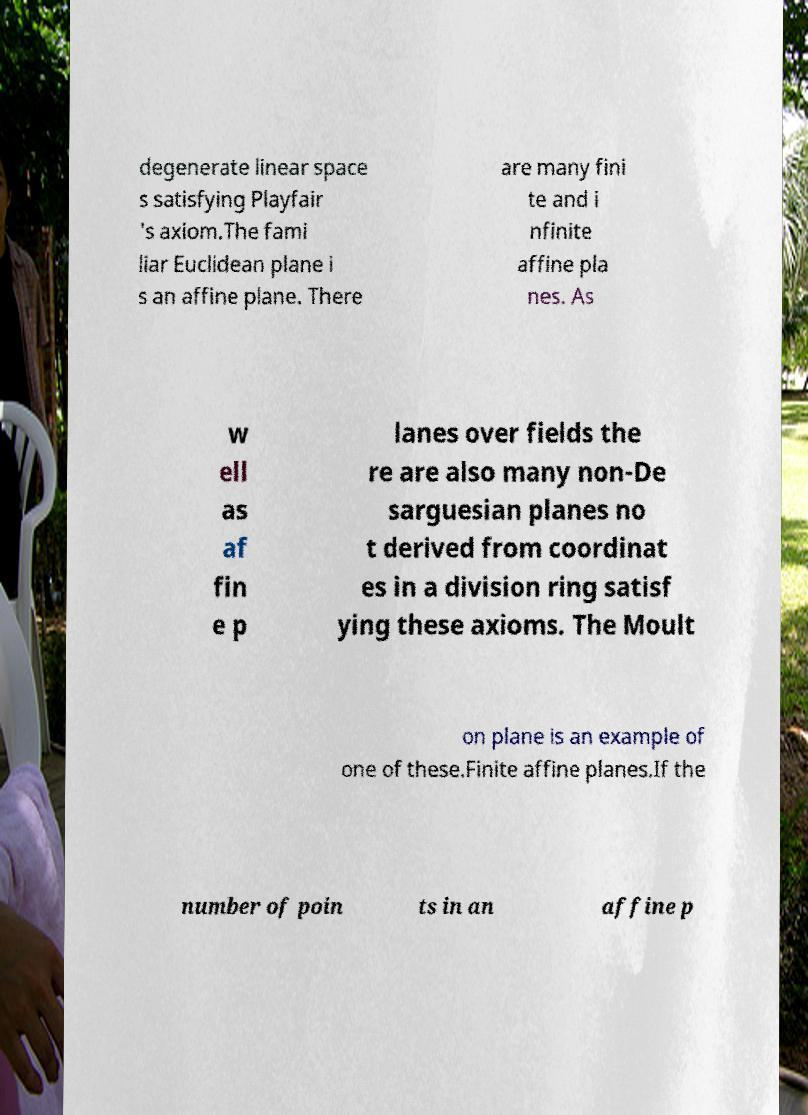For documentation purposes, I need the text within this image transcribed. Could you provide that? degenerate linear space s satisfying Playfair 's axiom.The fami liar Euclidean plane i s an affine plane. There are many fini te and i nfinite affine pla nes. As w ell as af fin e p lanes over fields the re are also many non-De sarguesian planes no t derived from coordinat es in a division ring satisf ying these axioms. The Moult on plane is an example of one of these.Finite affine planes.If the number of poin ts in an affine p 